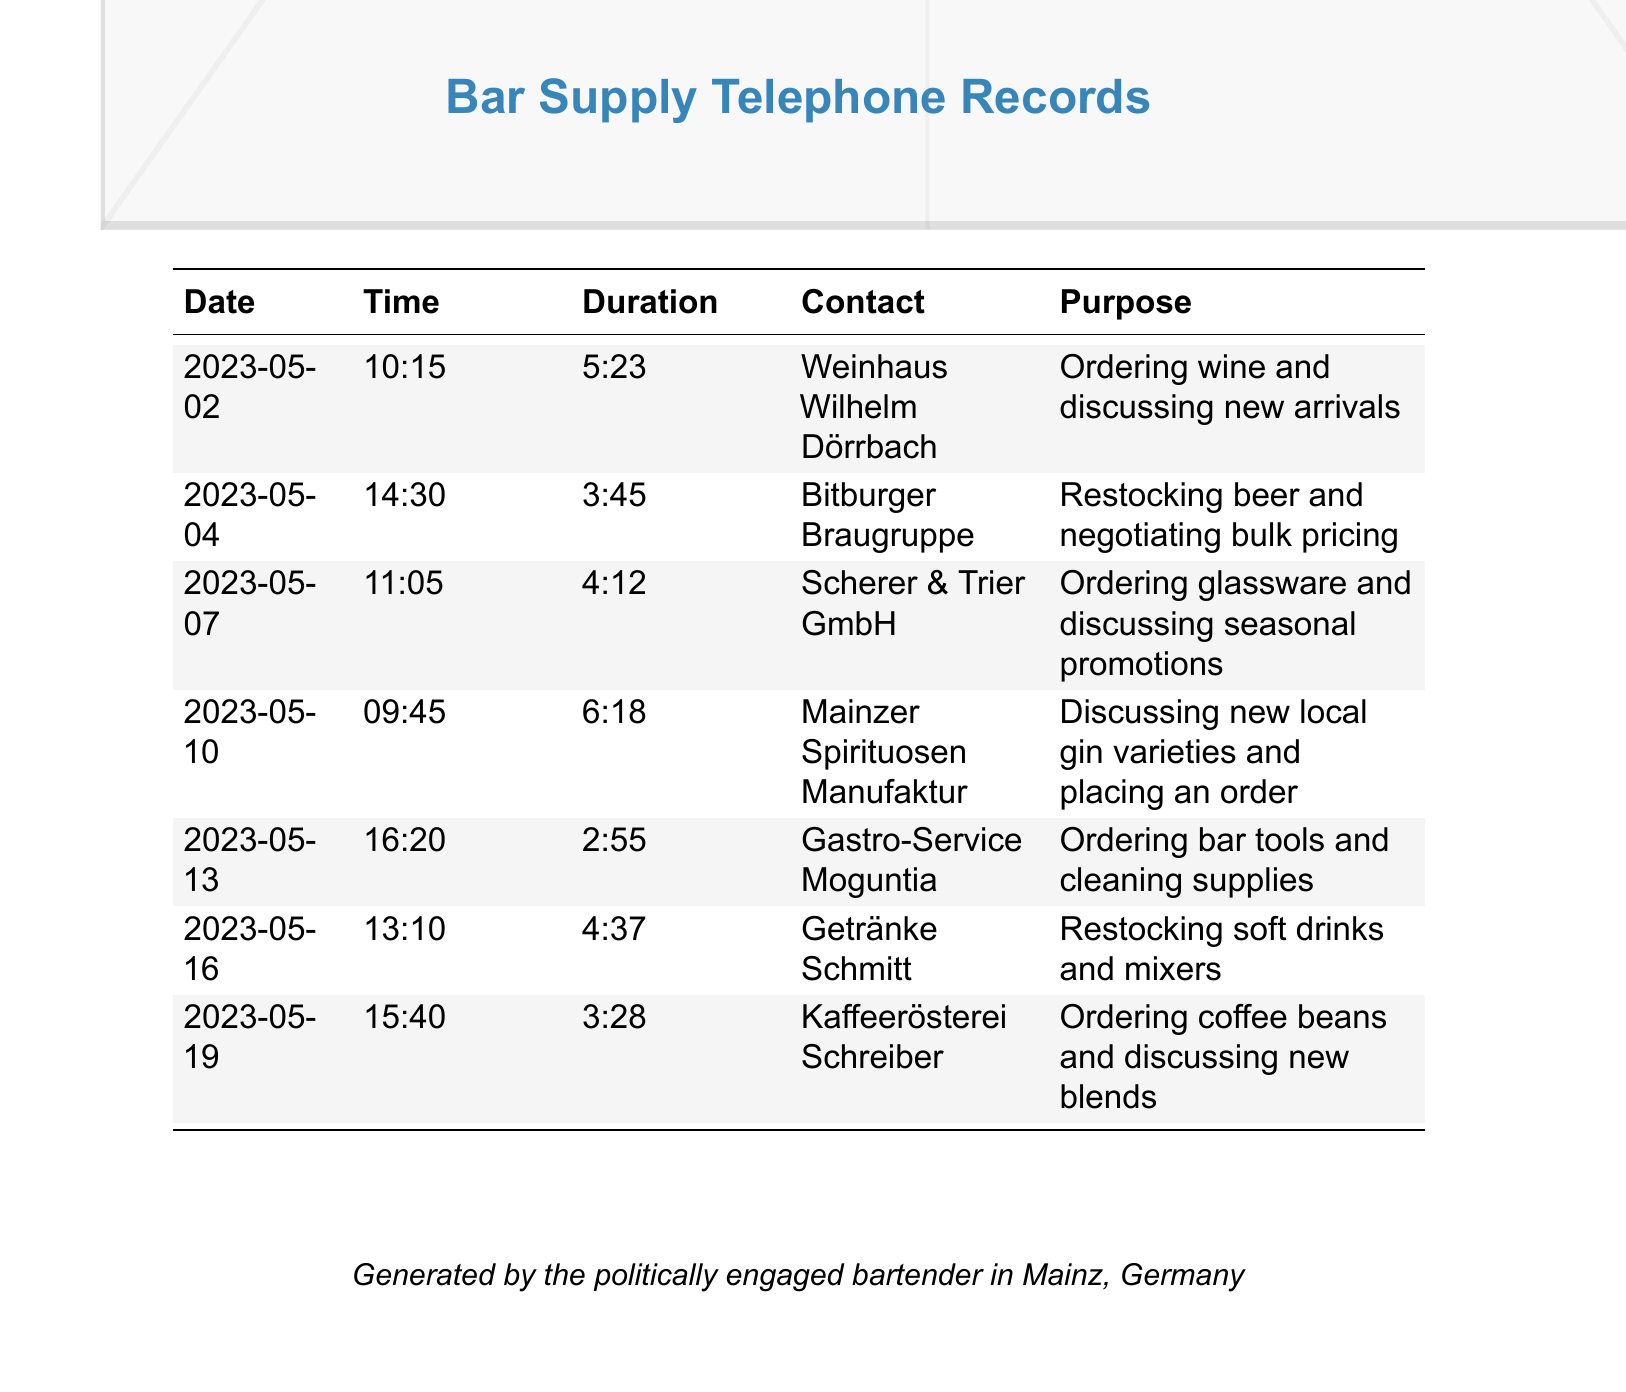What date was the call to Weinhaus Wilhelm Dörrbach? The document lists the dates of each call, and the call to Weinhaus Wilhelm Dörrbach occurred on 2023-05-02.
Answer: 2023-05-02 How long was the call with Getränke Schmitt? The duration of the call with Getränke Schmitt is specified in the document as 4:37.
Answer: 4:37 What was discussed during the call with Scherer & Trier GmbH? The purpose of the call with Scherer & Trier GmbH was ordering glassware and discussing seasonal promotions according to the document.
Answer: Ordering glassware and discussing seasonal promotions Which supplier was contacted for restocking beer? The document indicates that the contact for restocking beer was Bitburger Braugruppe.
Answer: Bitburger Braugruppe How many calls were made in total as recorded in the document? The document lists a total of 7 calls made to various suppliers for bar supplies.
Answer: 7 Which bar supply was ordered from Kaffeerösterei Schreiber? The document provides that coffee beans were ordered during the call with Kaffeerösterei Schreiber.
Answer: Coffee beans Which two suppliers were contacted on May 10? The document shows that Mainzer Spirituosen Manufaktur was contacted on May 10 and no other supplier on that date; it is a single call concerning gin varieties.
Answer: Mainzer Spirituosen Manufaktur What is the average duration of the calls based on the records? The document presents individual durations that would need to be averaged for an exact time, but the shortest recorded call is 2:55 and the longest is 6:18.
Answer: Requires calculation (Average not provided directly) What type of business is Getränke Schmitt primarily associated with? The purpose of the calls indicates beverages, specifically, that the call involved restocking soft drinks and mixers.
Answer: Soft drinks and mixers 